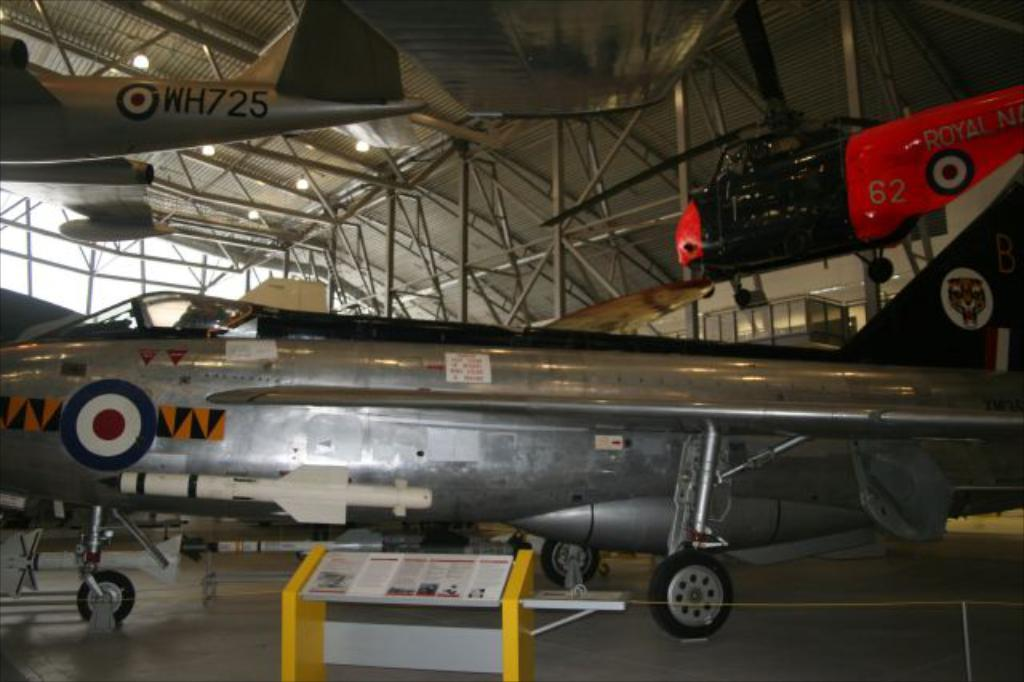Provide a one-sentence caption for the provided image. A Royal Navy helicopter is suspended from the ceiling. 